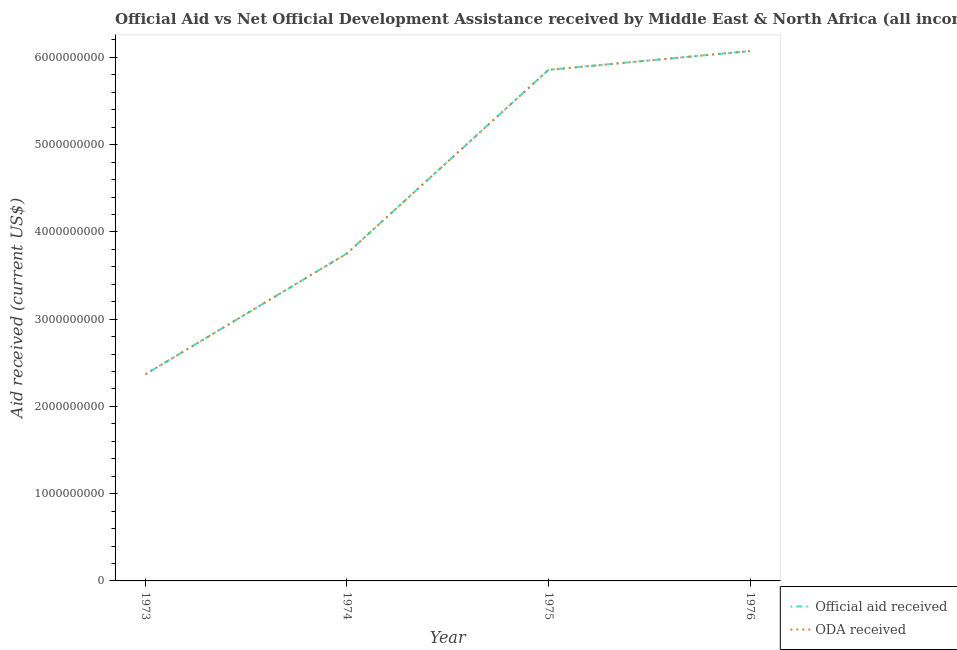Does the line corresponding to official aid received intersect with the line corresponding to oda received?
Your response must be concise. Yes. What is the official aid received in 1973?
Ensure brevity in your answer.  2.37e+09. Across all years, what is the maximum official aid received?
Your answer should be very brief. 6.07e+09. Across all years, what is the minimum official aid received?
Offer a very short reply. 2.37e+09. In which year was the official aid received maximum?
Provide a short and direct response. 1976. In which year was the oda received minimum?
Your response must be concise. 1973. What is the total oda received in the graph?
Ensure brevity in your answer.  1.81e+1. What is the difference between the official aid received in 1974 and that in 1976?
Your answer should be very brief. -2.32e+09. What is the difference between the official aid received in 1976 and the oda received in 1973?
Offer a terse response. 3.71e+09. What is the average oda received per year?
Provide a short and direct response. 4.51e+09. In the year 1974, what is the difference between the oda received and official aid received?
Make the answer very short. 0. What is the ratio of the oda received in 1974 to that in 1975?
Your answer should be compact. 0.64. Is the difference between the official aid received in 1975 and 1976 greater than the difference between the oda received in 1975 and 1976?
Your answer should be very brief. No. What is the difference between the highest and the second highest official aid received?
Your response must be concise. 2.16e+08. What is the difference between the highest and the lowest official aid received?
Provide a succinct answer. 3.71e+09. How many lines are there?
Keep it short and to the point. 2. Are the values on the major ticks of Y-axis written in scientific E-notation?
Ensure brevity in your answer.  No. Does the graph contain any zero values?
Provide a short and direct response. No. Does the graph contain grids?
Provide a succinct answer. No. How many legend labels are there?
Your answer should be very brief. 2. What is the title of the graph?
Ensure brevity in your answer.  Official Aid vs Net Official Development Assistance received by Middle East & North Africa (all income levels) . What is the label or title of the Y-axis?
Make the answer very short. Aid received (current US$). What is the Aid received (current US$) of Official aid received in 1973?
Your answer should be compact. 2.37e+09. What is the Aid received (current US$) in ODA received in 1973?
Keep it short and to the point. 2.37e+09. What is the Aid received (current US$) of Official aid received in 1974?
Provide a succinct answer. 3.75e+09. What is the Aid received (current US$) of ODA received in 1974?
Give a very brief answer. 3.75e+09. What is the Aid received (current US$) of Official aid received in 1975?
Offer a terse response. 5.86e+09. What is the Aid received (current US$) of ODA received in 1975?
Keep it short and to the point. 5.86e+09. What is the Aid received (current US$) of Official aid received in 1976?
Your response must be concise. 6.07e+09. What is the Aid received (current US$) in ODA received in 1976?
Your response must be concise. 6.07e+09. Across all years, what is the maximum Aid received (current US$) of Official aid received?
Your answer should be very brief. 6.07e+09. Across all years, what is the maximum Aid received (current US$) in ODA received?
Provide a short and direct response. 6.07e+09. Across all years, what is the minimum Aid received (current US$) of Official aid received?
Offer a very short reply. 2.37e+09. Across all years, what is the minimum Aid received (current US$) in ODA received?
Make the answer very short. 2.37e+09. What is the total Aid received (current US$) of Official aid received in the graph?
Your answer should be very brief. 1.81e+1. What is the total Aid received (current US$) in ODA received in the graph?
Your answer should be compact. 1.81e+1. What is the difference between the Aid received (current US$) of Official aid received in 1973 and that in 1974?
Provide a short and direct response. -1.39e+09. What is the difference between the Aid received (current US$) in ODA received in 1973 and that in 1974?
Ensure brevity in your answer.  -1.39e+09. What is the difference between the Aid received (current US$) of Official aid received in 1973 and that in 1975?
Make the answer very short. -3.49e+09. What is the difference between the Aid received (current US$) of ODA received in 1973 and that in 1975?
Give a very brief answer. -3.49e+09. What is the difference between the Aid received (current US$) in Official aid received in 1973 and that in 1976?
Provide a succinct answer. -3.71e+09. What is the difference between the Aid received (current US$) of ODA received in 1973 and that in 1976?
Your response must be concise. -3.71e+09. What is the difference between the Aid received (current US$) of Official aid received in 1974 and that in 1975?
Ensure brevity in your answer.  -2.10e+09. What is the difference between the Aid received (current US$) of ODA received in 1974 and that in 1975?
Provide a succinct answer. -2.10e+09. What is the difference between the Aid received (current US$) of Official aid received in 1974 and that in 1976?
Offer a terse response. -2.32e+09. What is the difference between the Aid received (current US$) of ODA received in 1974 and that in 1976?
Keep it short and to the point. -2.32e+09. What is the difference between the Aid received (current US$) in Official aid received in 1975 and that in 1976?
Offer a very short reply. -2.16e+08. What is the difference between the Aid received (current US$) of ODA received in 1975 and that in 1976?
Your response must be concise. -2.16e+08. What is the difference between the Aid received (current US$) of Official aid received in 1973 and the Aid received (current US$) of ODA received in 1974?
Offer a very short reply. -1.39e+09. What is the difference between the Aid received (current US$) of Official aid received in 1973 and the Aid received (current US$) of ODA received in 1975?
Offer a very short reply. -3.49e+09. What is the difference between the Aid received (current US$) of Official aid received in 1973 and the Aid received (current US$) of ODA received in 1976?
Keep it short and to the point. -3.71e+09. What is the difference between the Aid received (current US$) of Official aid received in 1974 and the Aid received (current US$) of ODA received in 1975?
Make the answer very short. -2.10e+09. What is the difference between the Aid received (current US$) in Official aid received in 1974 and the Aid received (current US$) in ODA received in 1976?
Keep it short and to the point. -2.32e+09. What is the difference between the Aid received (current US$) in Official aid received in 1975 and the Aid received (current US$) in ODA received in 1976?
Make the answer very short. -2.16e+08. What is the average Aid received (current US$) of Official aid received per year?
Your answer should be very brief. 4.51e+09. What is the average Aid received (current US$) of ODA received per year?
Make the answer very short. 4.51e+09. In the year 1973, what is the difference between the Aid received (current US$) in Official aid received and Aid received (current US$) in ODA received?
Provide a succinct answer. 0. In the year 1976, what is the difference between the Aid received (current US$) in Official aid received and Aid received (current US$) in ODA received?
Ensure brevity in your answer.  0. What is the ratio of the Aid received (current US$) in Official aid received in 1973 to that in 1974?
Offer a very short reply. 0.63. What is the ratio of the Aid received (current US$) in ODA received in 1973 to that in 1974?
Offer a very short reply. 0.63. What is the ratio of the Aid received (current US$) in Official aid received in 1973 to that in 1975?
Give a very brief answer. 0.4. What is the ratio of the Aid received (current US$) of ODA received in 1973 to that in 1975?
Provide a short and direct response. 0.4. What is the ratio of the Aid received (current US$) of Official aid received in 1973 to that in 1976?
Keep it short and to the point. 0.39. What is the ratio of the Aid received (current US$) in ODA received in 1973 to that in 1976?
Your response must be concise. 0.39. What is the ratio of the Aid received (current US$) in Official aid received in 1974 to that in 1975?
Keep it short and to the point. 0.64. What is the ratio of the Aid received (current US$) in ODA received in 1974 to that in 1975?
Keep it short and to the point. 0.64. What is the ratio of the Aid received (current US$) of Official aid received in 1974 to that in 1976?
Your answer should be compact. 0.62. What is the ratio of the Aid received (current US$) of ODA received in 1974 to that in 1976?
Provide a short and direct response. 0.62. What is the ratio of the Aid received (current US$) in Official aid received in 1975 to that in 1976?
Keep it short and to the point. 0.96. What is the ratio of the Aid received (current US$) of ODA received in 1975 to that in 1976?
Ensure brevity in your answer.  0.96. What is the difference between the highest and the second highest Aid received (current US$) in Official aid received?
Keep it short and to the point. 2.16e+08. What is the difference between the highest and the second highest Aid received (current US$) in ODA received?
Provide a short and direct response. 2.16e+08. What is the difference between the highest and the lowest Aid received (current US$) in Official aid received?
Provide a short and direct response. 3.71e+09. What is the difference between the highest and the lowest Aid received (current US$) in ODA received?
Provide a short and direct response. 3.71e+09. 